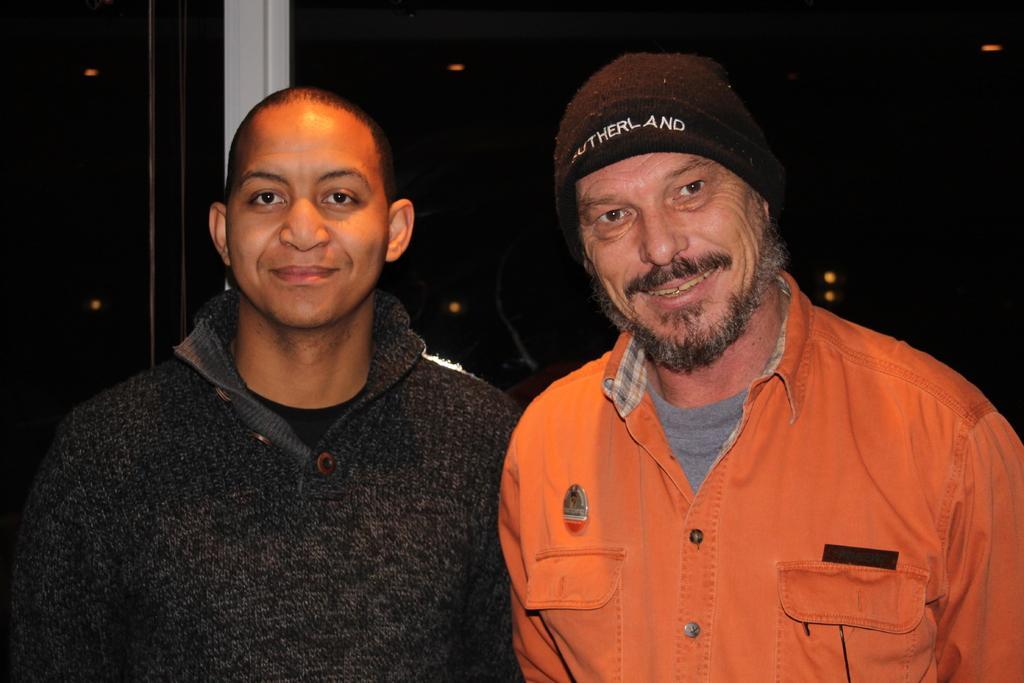Could you give a brief overview of what you see in this image? In this picture there are two men in the center of the image. 